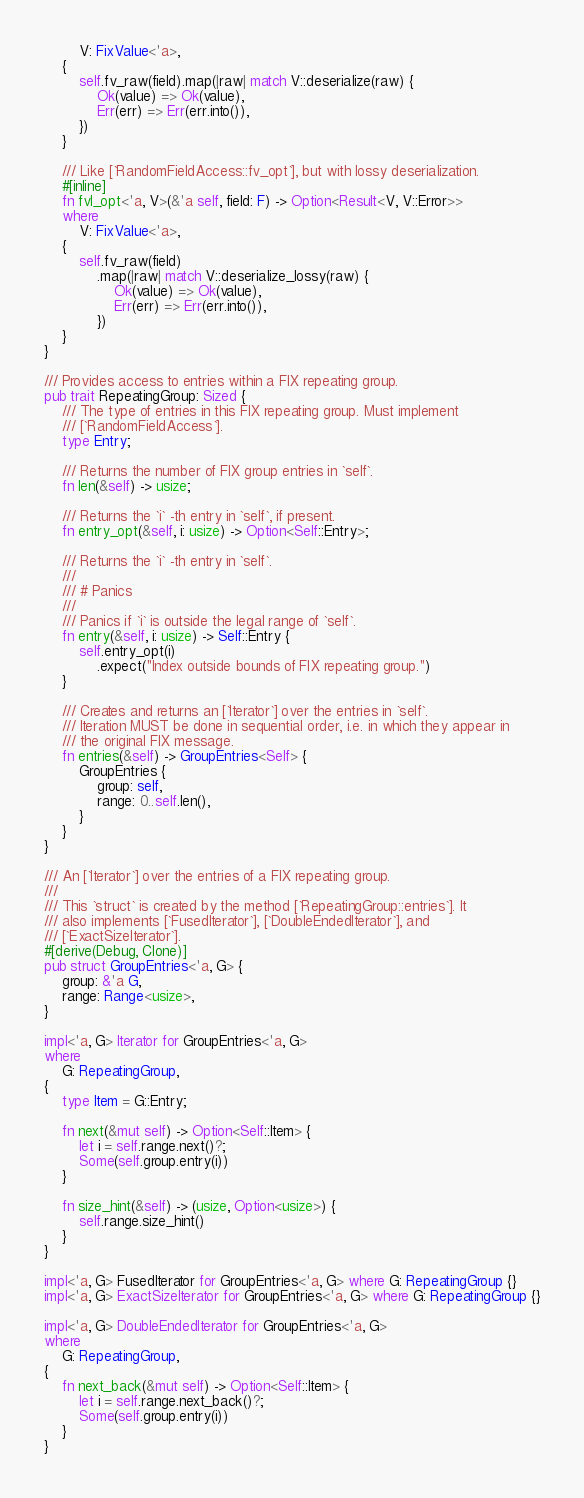Convert code to text. <code><loc_0><loc_0><loc_500><loc_500><_Rust_>        V: FixValue<'a>,
    {
        self.fv_raw(field).map(|raw| match V::deserialize(raw) {
            Ok(value) => Ok(value),
            Err(err) => Err(err.into()),
        })
    }

    /// Like [`RandomFieldAccess::fv_opt`], but with lossy deserialization.
    #[inline]
    fn fvl_opt<'a, V>(&'a self, field: F) -> Option<Result<V, V::Error>>
    where
        V: FixValue<'a>,
    {
        self.fv_raw(field)
            .map(|raw| match V::deserialize_lossy(raw) {
                Ok(value) => Ok(value),
                Err(err) => Err(err.into()),
            })
    }
}

/// Provides access to entries within a FIX repeating group.
pub trait RepeatingGroup: Sized {
    /// The type of entries in this FIX repeating group. Must implement
    /// [`RandomFieldAccess`].
    type Entry;

    /// Returns the number of FIX group entries in `self`.
    fn len(&self) -> usize;

    /// Returns the `i` -th entry in `self`, if present.
    fn entry_opt(&self, i: usize) -> Option<Self::Entry>;

    /// Returns the `i` -th entry in `self`.
    ///
    /// # Panics
    ///
    /// Panics if `i` is outside the legal range of `self`.
    fn entry(&self, i: usize) -> Self::Entry {
        self.entry_opt(i)
            .expect("Index outside bounds of FIX repeating group.")
    }

    /// Creates and returns an [`Iterator`] over the entries in `self`.
    /// Iteration MUST be done in sequential order, i.e. in which they appear in
    /// the original FIX message.
    fn entries(&self) -> GroupEntries<Self> {
        GroupEntries {
            group: self,
            range: 0..self.len(),
        }
    }
}

/// An [`Iterator`] over the entries of a FIX repeating group.
///
/// This `struct` is created by the method [`RepeatingGroup::entries`]. It
/// also implements [`FusedIterator`], [`DoubleEndedIterator`], and
/// [`ExactSizeIterator`].
#[derive(Debug, Clone)]
pub struct GroupEntries<'a, G> {
    group: &'a G,
    range: Range<usize>,
}

impl<'a, G> Iterator for GroupEntries<'a, G>
where
    G: RepeatingGroup,
{
    type Item = G::Entry;

    fn next(&mut self) -> Option<Self::Item> {
        let i = self.range.next()?;
        Some(self.group.entry(i))
    }

    fn size_hint(&self) -> (usize, Option<usize>) {
        self.range.size_hint()
    }
}

impl<'a, G> FusedIterator for GroupEntries<'a, G> where G: RepeatingGroup {}
impl<'a, G> ExactSizeIterator for GroupEntries<'a, G> where G: RepeatingGroup {}

impl<'a, G> DoubleEndedIterator for GroupEntries<'a, G>
where
    G: RepeatingGroup,
{
    fn next_back(&mut self) -> Option<Self::Item> {
        let i = self.range.next_back()?;
        Some(self.group.entry(i))
    }
}
</code> 